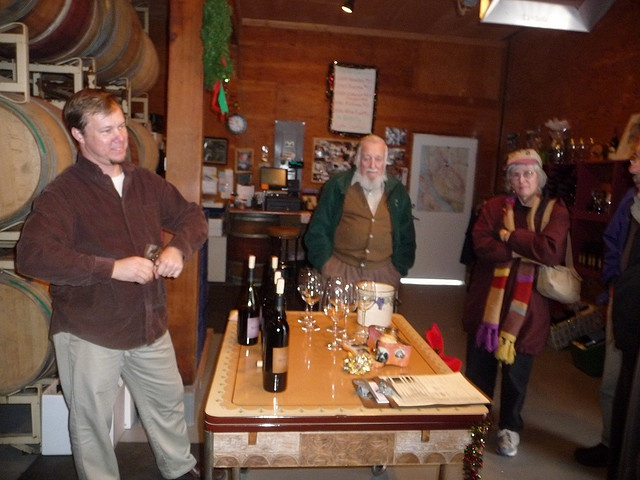Describe the objects in this image and their specific colors. I can see dining table in maroon, tan, black, and gray tones, people in maroon, darkgray, gray, and lightpink tones, people in maroon, black, and gray tones, people in maroon, black, and brown tones, and people in black, gray, and maroon tones in this image. 